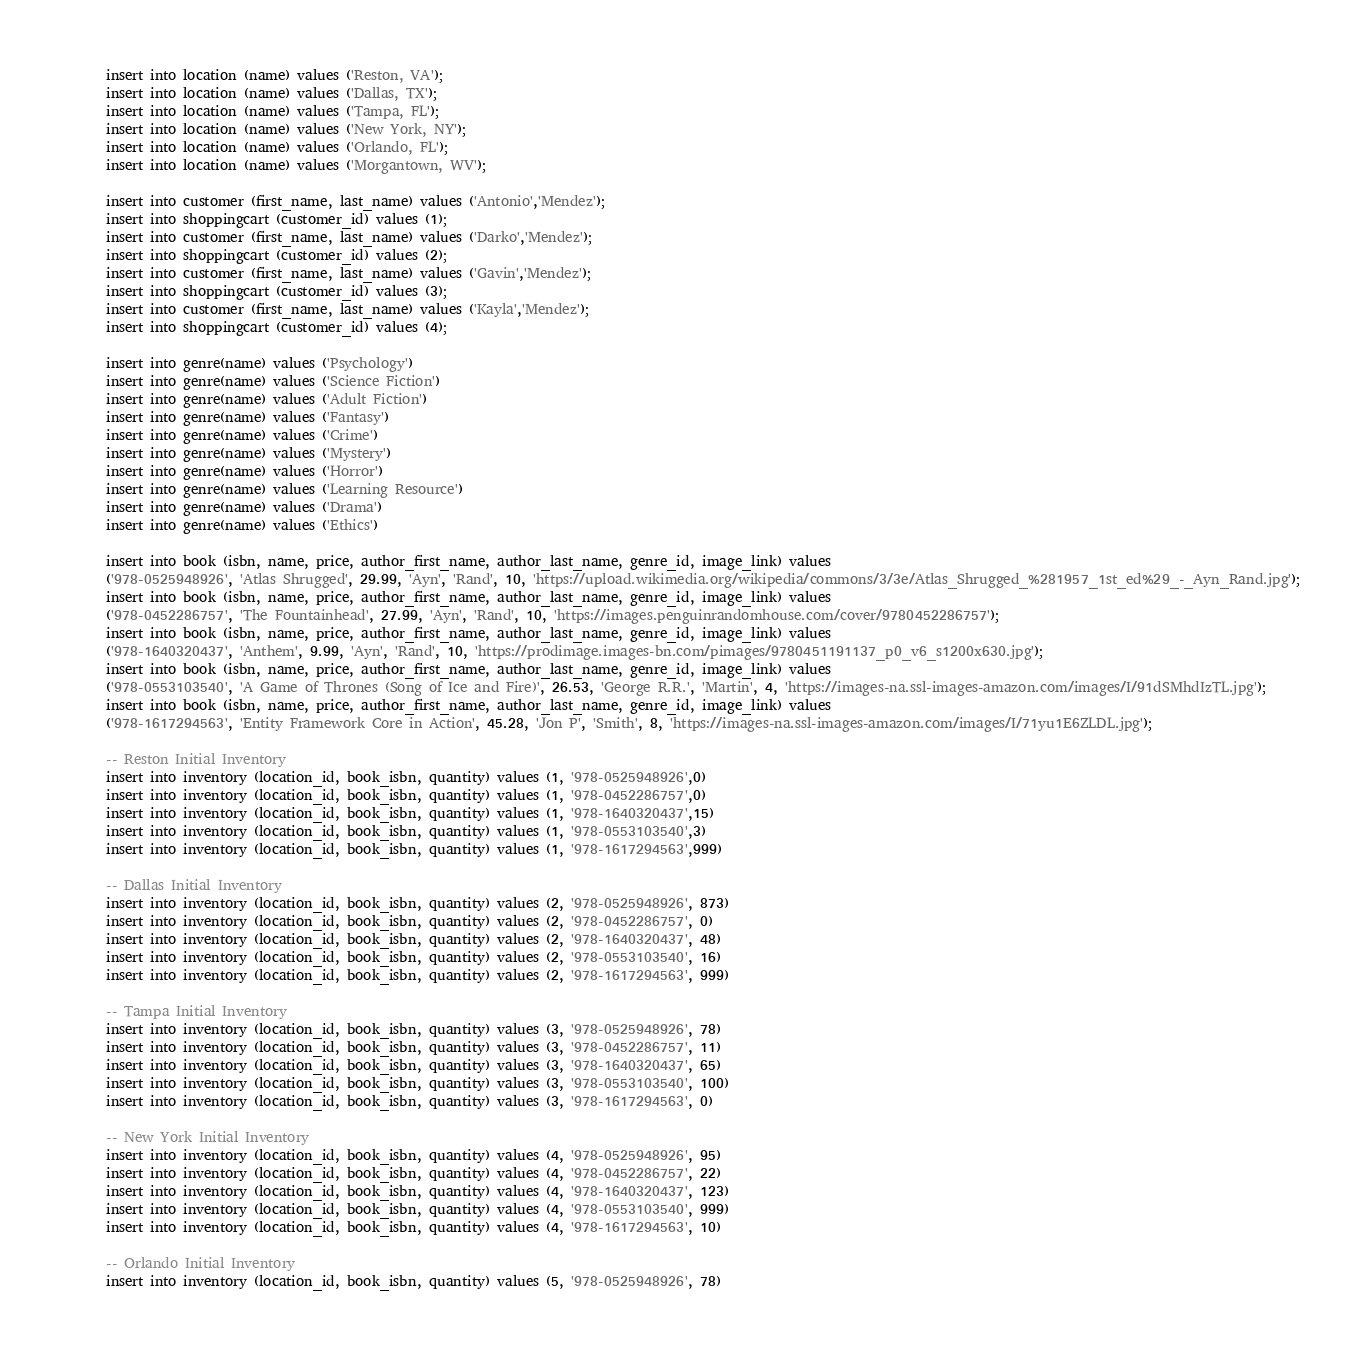Convert code to text. <code><loc_0><loc_0><loc_500><loc_500><_SQL_>insert into location (name) values ('Reston, VA');
insert into location (name) values ('Dallas, TX');
insert into location (name) values ('Tampa, FL');
insert into location (name) values ('New York, NY');
insert into location (name) values ('Orlando, FL');
insert into location (name) values ('Morgantown, WV');

insert into customer (first_name, last_name) values ('Antonio','Mendez');
insert into shoppingcart (customer_id) values (1);
insert into customer (first_name, last_name) values ('Darko','Mendez');
insert into shoppingcart (customer_id) values (2);
insert into customer (first_name, last_name) values ('Gavin','Mendez');
insert into shoppingcart (customer_id) values (3);
insert into customer (first_name, last_name) values ('Kayla','Mendez'); 
insert into shoppingcart (customer_id) values (4);

insert into genre(name) values ('Psychology')
insert into genre(name) values ('Science Fiction')
insert into genre(name) values ('Adult Fiction')
insert into genre(name) values ('Fantasy')
insert into genre(name) values ('Crime')
insert into genre(name) values ('Mystery')
insert into genre(name) values ('Horror')
insert into genre(name) values ('Learning Resource')
insert into genre(name) values ('Drama')
insert into genre(name) values ('Ethics')

insert into book (isbn, name, price, author_first_name, author_last_name, genre_id, image_link) values 
('978-0525948926', 'Atlas Shrugged', 29.99, 'Ayn', 'Rand', 10, 'https://upload.wikimedia.org/wikipedia/commons/3/3e/Atlas_Shrugged_%281957_1st_ed%29_-_Ayn_Rand.jpg');
insert into book (isbn, name, price, author_first_name, author_last_name, genre_id, image_link) values 
('978-0452286757', 'The Fountainhead', 27.99, 'Ayn', 'Rand', 10, 'https://images.penguinrandomhouse.com/cover/9780452286757');
insert into book (isbn, name, price, author_first_name, author_last_name, genre_id, image_link) values 
('978-1640320437', 'Anthem', 9.99, 'Ayn', 'Rand', 10, 'https://prodimage.images-bn.com/pimages/9780451191137_p0_v6_s1200x630.jpg');
insert into book (isbn, name, price, author_first_name, author_last_name, genre_id, image_link) values 
('978-0553103540', 'A Game of Thrones (Song of Ice and Fire)', 26.53, 'George R.R.', 'Martin', 4, 'https://images-na.ssl-images-amazon.com/images/I/91dSMhdIzTL.jpg');
insert into book (isbn, name, price, author_first_name, author_last_name, genre_id, image_link) values 
('978-1617294563', 'Entity Framework Core in Action', 45.28, 'Jon P', 'Smith', 8, 'https://images-na.ssl-images-amazon.com/images/I/71yu1E6ZLDL.jpg');

-- Reston Initial Inventory
insert into inventory (location_id, book_isbn, quantity) values (1, '978-0525948926',0)
insert into inventory (location_id, book_isbn, quantity) values (1, '978-0452286757',0)
insert into inventory (location_id, book_isbn, quantity) values (1, '978-1640320437',15)
insert into inventory (location_id, book_isbn, quantity) values (1, '978-0553103540',3)
insert into inventory (location_id, book_isbn, quantity) values (1, '978-1617294563',999)

-- Dallas Initial Inventory
insert into inventory (location_id, book_isbn, quantity) values (2, '978-0525948926', 873)
insert into inventory (location_id, book_isbn, quantity) values (2, '978-0452286757', 0)
insert into inventory (location_id, book_isbn, quantity) values (2, '978-1640320437', 48)
insert into inventory (location_id, book_isbn, quantity) values (2, '978-0553103540', 16)
insert into inventory (location_id, book_isbn, quantity) values (2, '978-1617294563', 999)

-- Tampa Initial Inventory
insert into inventory (location_id, book_isbn, quantity) values (3, '978-0525948926', 78)
insert into inventory (location_id, book_isbn, quantity) values (3, '978-0452286757', 11)
insert into inventory (location_id, book_isbn, quantity) values (3, '978-1640320437', 65)
insert into inventory (location_id, book_isbn, quantity) values (3, '978-0553103540', 100)
insert into inventory (location_id, book_isbn, quantity) values (3, '978-1617294563', 0)

-- New York Initial Inventory
insert into inventory (location_id, book_isbn, quantity) values (4, '978-0525948926', 95)
insert into inventory (location_id, book_isbn, quantity) values (4, '978-0452286757', 22)
insert into inventory (location_id, book_isbn, quantity) values (4, '978-1640320437', 123)
insert into inventory (location_id, book_isbn, quantity) values (4, '978-0553103540', 999)
insert into inventory (location_id, book_isbn, quantity) values (4, '978-1617294563', 10)

-- Orlando Initial Inventory
insert into inventory (location_id, book_isbn, quantity) values (5, '978-0525948926', 78)</code> 